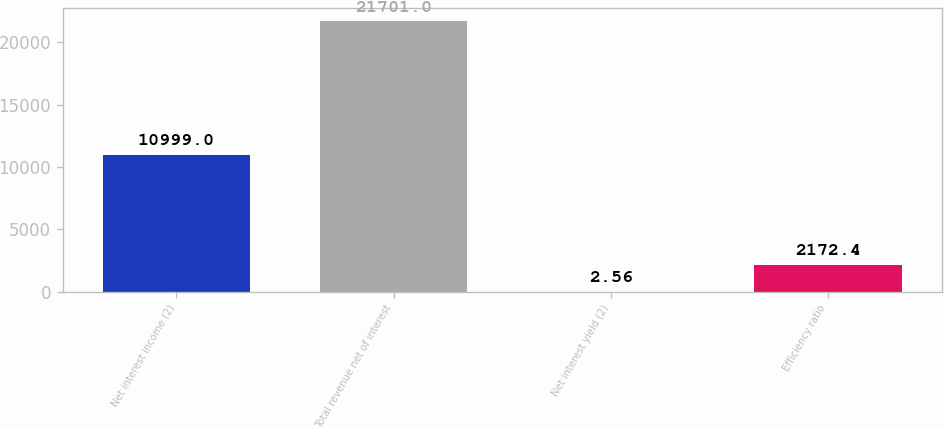<chart> <loc_0><loc_0><loc_500><loc_500><bar_chart><fcel>Net interest income (2)<fcel>Total revenue net of interest<fcel>Net interest yield (2)<fcel>Efficiency ratio<nl><fcel>10999<fcel>21701<fcel>2.56<fcel>2172.4<nl></chart> 